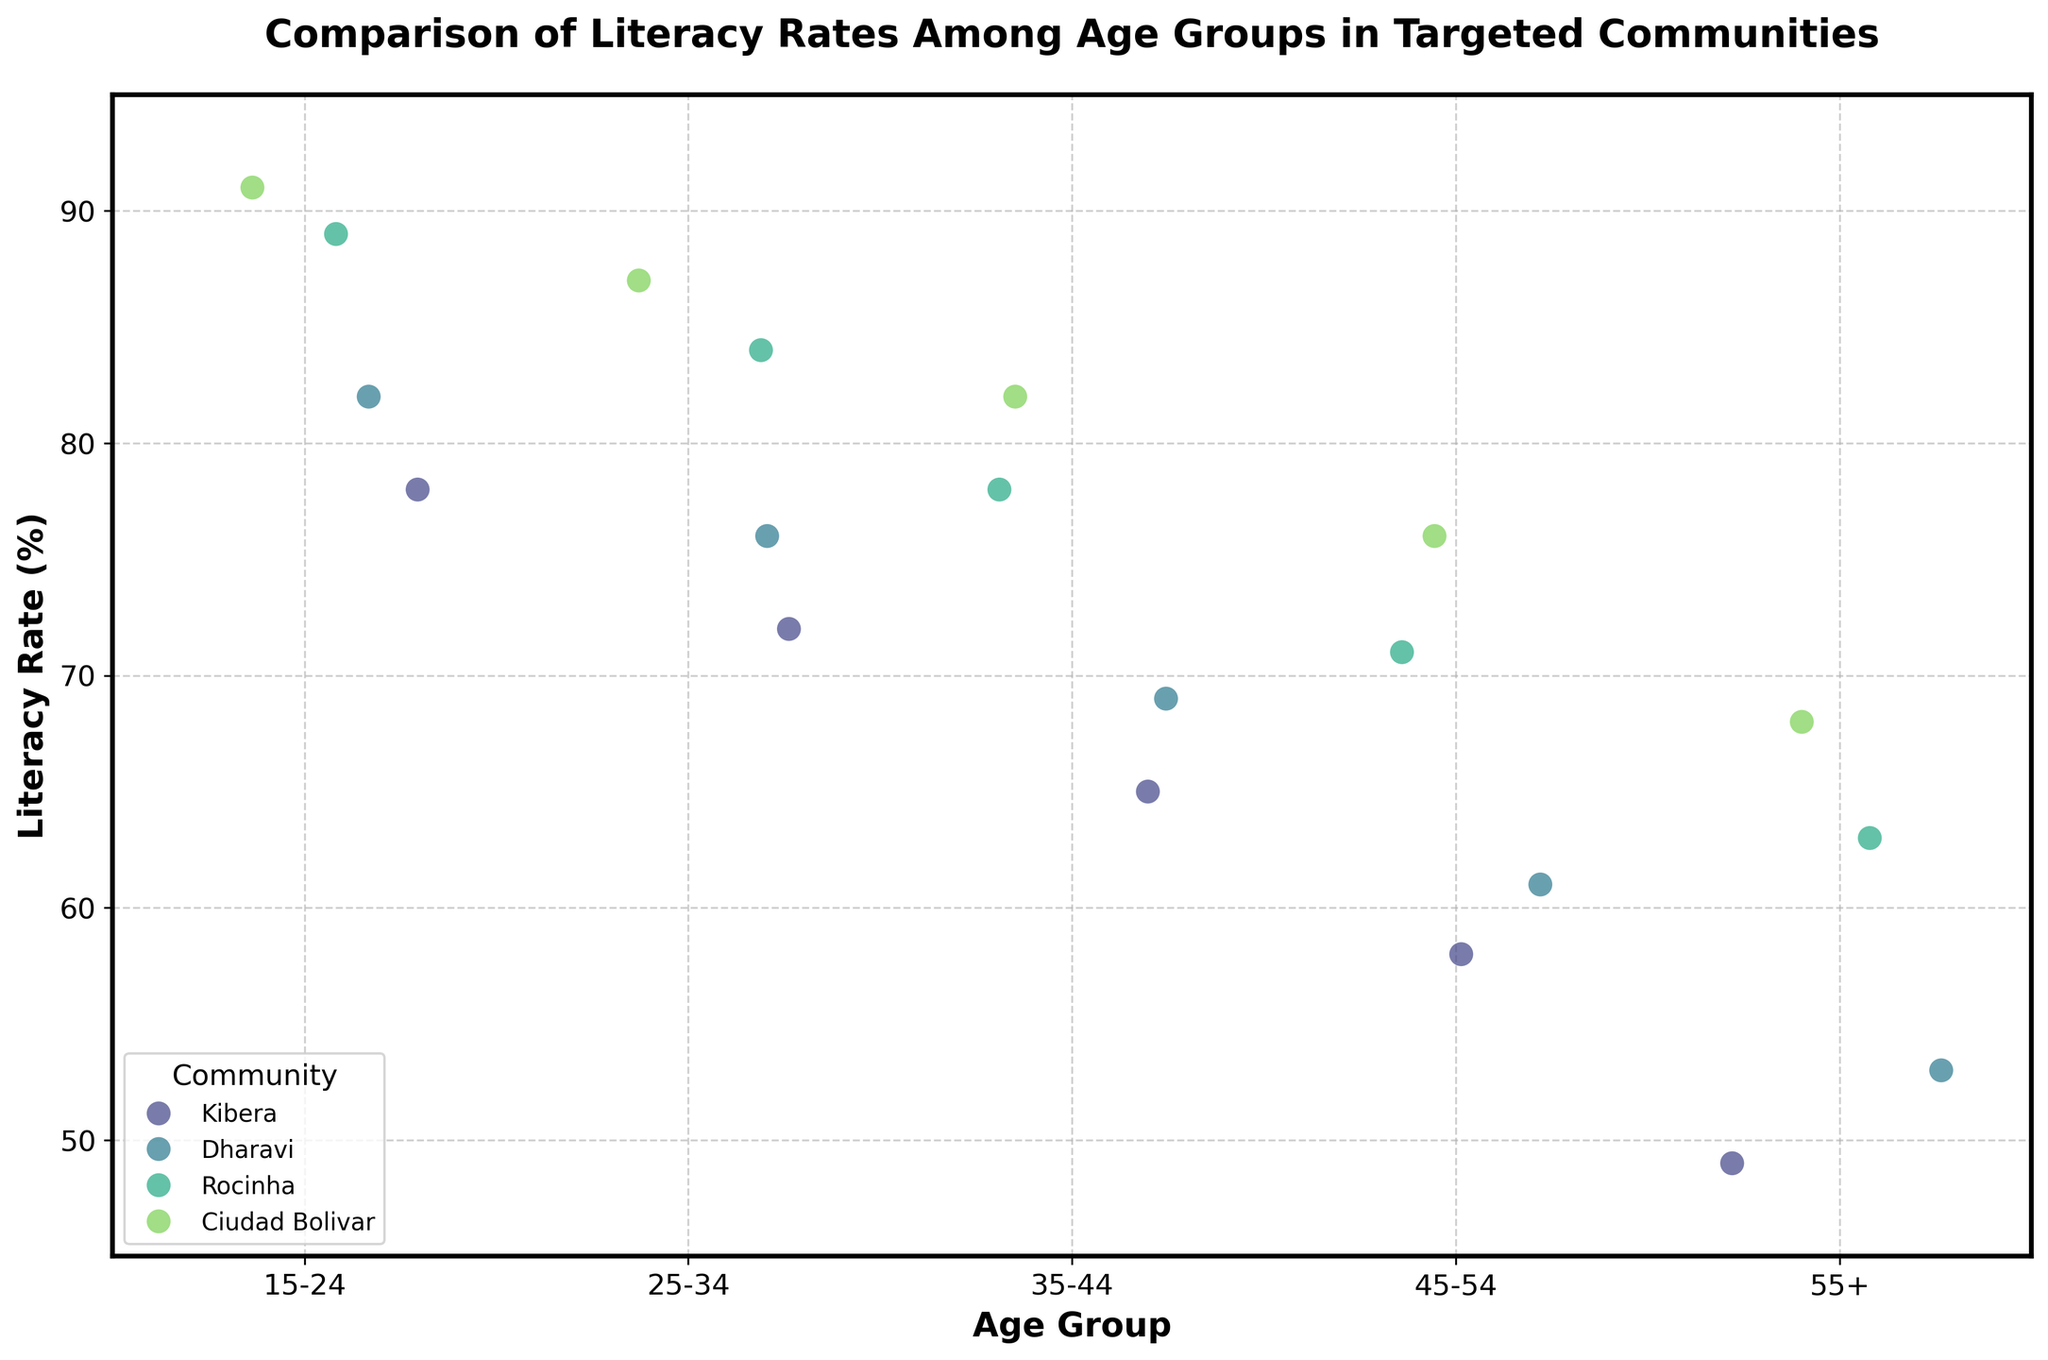What's the title of the plot? The title is found at the top of the plot and it clearly states the purpose of the figure as "Comparison of Literacy Rates Among Age Groups in Targeted Communities."
Answer: Comparison of Literacy Rates Among Age Groups in Targeted Communities What is the literacy rate for the 45-54 age group in Dharavi? Locate the data points on the strip plot that correspond to the 45-54 age group for the community of Dharavi, which are represented in the plot with different hues. Here, the literacy rate is around 61.
Answer: 61 Which community has the highest literacy rate for the 15-24 age group? Look for the highest data point among the strips corresponding to the 15-24 age group. The community with the highest point is Ciudad Bolivar with a literacy rate of 91.
Answer: Ciudad Bolivar How does the literacy rate in the 55+ age group in Rocinha compare to that in Ciudad Bolivar? Locate the points corresponding to the 55+ age group for Rocinha and Ciudad Bolivar. Rocinha has a literacy rate of 63, while Ciudad Bolivar has a rate of 68. Therefore, Ciudad Bolivar's rate is higher.
Answer: Ciudad Bolivar has a higher literacy rate What trend can be observed as age increases in the literacy rates for Kibera? Observe the data points for Kibera across the age groups (from 15-24 to 55+). The points show a declining pattern, indicating that literacy rates decrease as age increases in Kibera.
Answer: Literacy rates decrease Which community shows the smallest drop in literacy rates between the 25-34 and 35-44 age groups? Calculate the differences in literacy rates between the 25-34 and 35-44 age groups for each community. Kibera has a drop of 7, Dharavi a drop of 7, Rocinha a drop of 6, and Ciudad Bolivar a drop of 5. The smallest drop is in Ciudad Bolivar.
Answer: Ciudad Bolivar What is the average literacy rate for all age groups in Ciudad Bolivar? Sum the literacy rates for all age groups in Ciudad Bolivar (91, 87, 82, 76, 68) and divide by the number of age groups. The average is (91+87+82+76+68)/5 = 80.8.
Answer: 80.8 For the community Dharavi, what is the difference in literacy rates between the youngest and oldest age groups? Subtract the literacy rate of the 55+ age group from that of the 15-24 age group in Dharavi. The difference is 82 - 53.
Answer: 29 Which community has the lowest literacy rate for any age group in the plot? Examine all the data points and identify the lowest literacy rate. The lowest rate is in Kibera for the 55+ age group at 49.
Answer: Kibera 